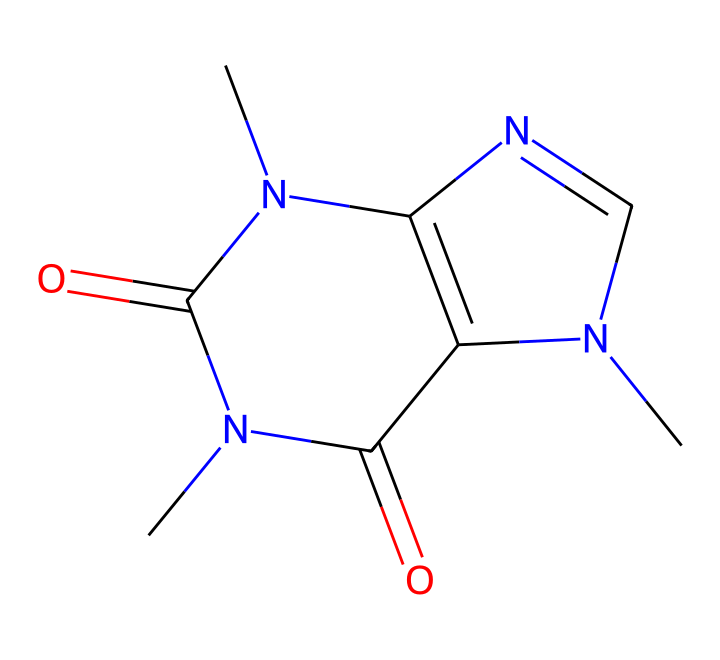What is the molecular formula of caffeine? Caffeine has a structure that includes carbon (C), nitrogen (N), and oxygen (O) atoms. Counting the atoms from the SMILES string CN1C=NC2=C1C(=O)N(C(=O)N2C), we find there are 8 carbon atoms, 10 hydrogen atoms, 4 nitrogen atoms, and 2 oxygen atoms, which gives the molecular formula C8H10N4O2.
Answer: C8H10N4O2 How many nitrogen atoms are present in caffeine's structure? From the SMILES representation, we can see that there are 4 occurrences of the nitrogen atom (N). Counting them confirms this number.
Answer: 4 What type of bonds are present in caffeine's chemical structure? The chemical structure shows single and double bonds, identifiable through the SMILES notation where '=' denotes a double bond and single bonds are implied between atoms not connected by '='. A closer inspection shows a combination of both bond types throughout the structure.
Answer: single and double bonds What does caffeine primarily stimulate in the nervous system? Caffeine primarily acts as an antagonist to adenosine receptors in the nervous system, which helps to increase alertness and reduce fatigue. This action is critical to understanding its stimulating effects.
Answer: adenosine receptors How does caffeine affect neurotransmitter release? Caffeine enhances the release of neurotransmitters like dopamine and norepinephrine by inhibiting the inhibitory effects of adenosine, making excitatory signaling more dominant in the nervous system. This leads to increased neuronal activity.
Answer: enhances neurotransmitter release Which part of caffeine's structure is responsible for its psychoactive effects? The presence of the nitrogen-containing groups in the structure is significant; they facilitate interactions with adenosine receptors, contributing to its psychoactive properties.
Answer: nitrogen-containing groups 